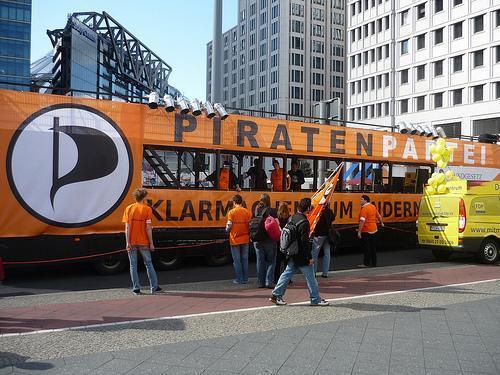How many people outside of the bus are wearing orange?
Give a very brief answer. 3. How many people are outside the bus?
Give a very brief answer. 7. 